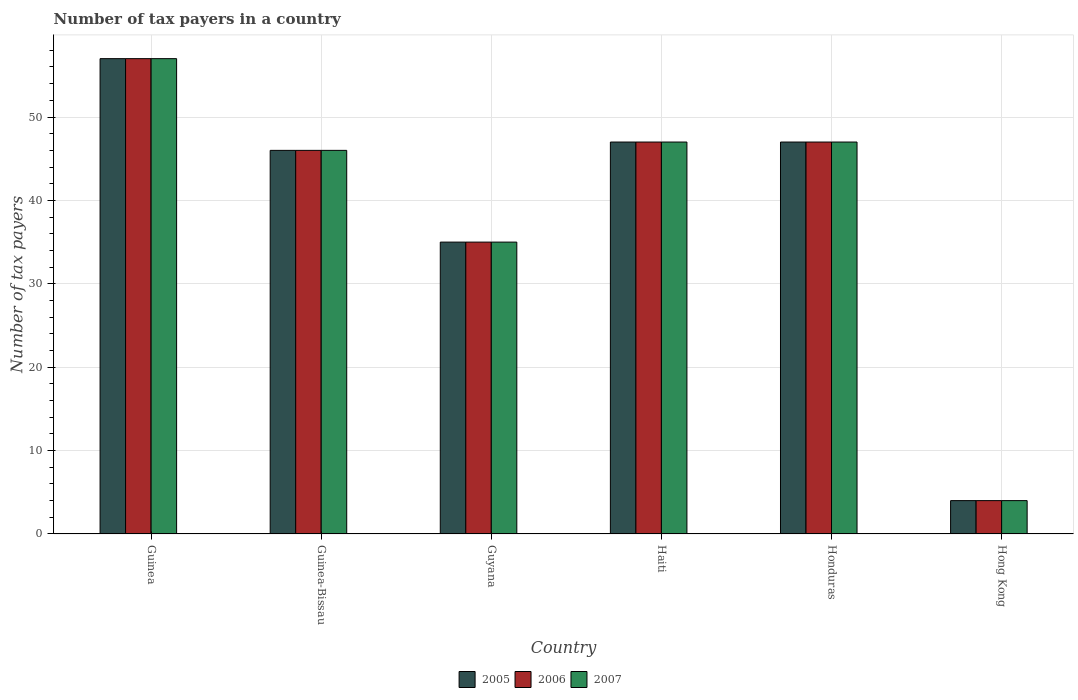How many different coloured bars are there?
Provide a short and direct response. 3. How many groups of bars are there?
Provide a succinct answer. 6. Are the number of bars per tick equal to the number of legend labels?
Make the answer very short. Yes. Are the number of bars on each tick of the X-axis equal?
Offer a very short reply. Yes. What is the label of the 6th group of bars from the left?
Offer a terse response. Hong Kong. In which country was the number of tax payers in in 2006 maximum?
Provide a succinct answer. Guinea. In which country was the number of tax payers in in 2006 minimum?
Your answer should be compact. Hong Kong. What is the total number of tax payers in in 2007 in the graph?
Your answer should be very brief. 236. What is the difference between the number of tax payers in in 2005 in Guinea and the number of tax payers in in 2007 in Honduras?
Make the answer very short. 10. What is the average number of tax payers in in 2005 per country?
Keep it short and to the point. 39.33. What is the ratio of the number of tax payers in in 2006 in Guyana to that in Haiti?
Your answer should be very brief. 0.74. Is the difference between the number of tax payers in in 2006 in Guyana and Haiti greater than the difference between the number of tax payers in in 2005 in Guyana and Haiti?
Provide a short and direct response. No. What is the difference between the highest and the second highest number of tax payers in in 2006?
Offer a terse response. 10. What is the difference between the highest and the lowest number of tax payers in in 2006?
Offer a terse response. 53. How many bars are there?
Make the answer very short. 18. How many countries are there in the graph?
Offer a terse response. 6. What is the difference between two consecutive major ticks on the Y-axis?
Your response must be concise. 10. Are the values on the major ticks of Y-axis written in scientific E-notation?
Ensure brevity in your answer.  No. Does the graph contain any zero values?
Make the answer very short. No. Where does the legend appear in the graph?
Make the answer very short. Bottom center. How many legend labels are there?
Your answer should be very brief. 3. How are the legend labels stacked?
Offer a very short reply. Horizontal. What is the title of the graph?
Ensure brevity in your answer.  Number of tax payers in a country. Does "2007" appear as one of the legend labels in the graph?
Your response must be concise. Yes. What is the label or title of the X-axis?
Offer a very short reply. Country. What is the label or title of the Y-axis?
Keep it short and to the point. Number of tax payers. What is the Number of tax payers of 2005 in Guinea?
Offer a terse response. 57. What is the Number of tax payers in 2005 in Guyana?
Provide a succinct answer. 35. What is the Number of tax payers in 2005 in Haiti?
Ensure brevity in your answer.  47. What is the Number of tax payers in 2006 in Haiti?
Offer a terse response. 47. What is the Number of tax payers of 2006 in Honduras?
Ensure brevity in your answer.  47. What is the Number of tax payers in 2005 in Hong Kong?
Ensure brevity in your answer.  4. Across all countries, what is the maximum Number of tax payers of 2005?
Give a very brief answer. 57. Across all countries, what is the minimum Number of tax payers of 2007?
Your response must be concise. 4. What is the total Number of tax payers in 2005 in the graph?
Offer a terse response. 236. What is the total Number of tax payers in 2006 in the graph?
Provide a short and direct response. 236. What is the total Number of tax payers of 2007 in the graph?
Your answer should be very brief. 236. What is the difference between the Number of tax payers in 2006 in Guinea and that in Guinea-Bissau?
Offer a terse response. 11. What is the difference between the Number of tax payers in 2007 in Guinea and that in Guinea-Bissau?
Keep it short and to the point. 11. What is the difference between the Number of tax payers in 2005 in Guinea and that in Guyana?
Provide a succinct answer. 22. What is the difference between the Number of tax payers in 2006 in Guinea and that in Haiti?
Your response must be concise. 10. What is the difference between the Number of tax payers in 2006 in Guinea and that in Honduras?
Offer a very short reply. 10. What is the difference between the Number of tax payers of 2007 in Guinea and that in Honduras?
Your response must be concise. 10. What is the difference between the Number of tax payers of 2006 in Guinea-Bissau and that in Guyana?
Provide a short and direct response. 11. What is the difference between the Number of tax payers of 2007 in Guinea-Bissau and that in Guyana?
Ensure brevity in your answer.  11. What is the difference between the Number of tax payers of 2006 in Guinea-Bissau and that in Haiti?
Your answer should be very brief. -1. What is the difference between the Number of tax payers of 2006 in Guinea-Bissau and that in Honduras?
Keep it short and to the point. -1. What is the difference between the Number of tax payers in 2006 in Guinea-Bissau and that in Hong Kong?
Provide a short and direct response. 42. What is the difference between the Number of tax payers of 2007 in Guyana and that in Haiti?
Ensure brevity in your answer.  -12. What is the difference between the Number of tax payers in 2006 in Guyana and that in Honduras?
Provide a short and direct response. -12. What is the difference between the Number of tax payers in 2005 in Guyana and that in Hong Kong?
Give a very brief answer. 31. What is the difference between the Number of tax payers of 2006 in Guyana and that in Hong Kong?
Provide a succinct answer. 31. What is the difference between the Number of tax payers in 2007 in Guyana and that in Hong Kong?
Provide a succinct answer. 31. What is the difference between the Number of tax payers in 2005 in Haiti and that in Honduras?
Ensure brevity in your answer.  0. What is the difference between the Number of tax payers in 2006 in Haiti and that in Honduras?
Your response must be concise. 0. What is the difference between the Number of tax payers of 2007 in Haiti and that in Hong Kong?
Offer a terse response. 43. What is the difference between the Number of tax payers of 2006 in Honduras and that in Hong Kong?
Your response must be concise. 43. What is the difference between the Number of tax payers in 2005 in Guinea and the Number of tax payers in 2006 in Guinea-Bissau?
Ensure brevity in your answer.  11. What is the difference between the Number of tax payers of 2005 in Guinea and the Number of tax payers of 2006 in Guyana?
Ensure brevity in your answer.  22. What is the difference between the Number of tax payers in 2005 in Guinea and the Number of tax payers in 2007 in Guyana?
Provide a succinct answer. 22. What is the difference between the Number of tax payers in 2006 in Guinea and the Number of tax payers in 2007 in Guyana?
Make the answer very short. 22. What is the difference between the Number of tax payers in 2006 in Guinea and the Number of tax payers in 2007 in Haiti?
Give a very brief answer. 10. What is the difference between the Number of tax payers of 2005 in Guinea and the Number of tax payers of 2006 in Honduras?
Your response must be concise. 10. What is the difference between the Number of tax payers of 2005 in Guinea and the Number of tax payers of 2007 in Honduras?
Offer a very short reply. 10. What is the difference between the Number of tax payers in 2005 in Guinea and the Number of tax payers in 2007 in Hong Kong?
Make the answer very short. 53. What is the difference between the Number of tax payers of 2006 in Guinea and the Number of tax payers of 2007 in Hong Kong?
Ensure brevity in your answer.  53. What is the difference between the Number of tax payers of 2005 in Guinea-Bissau and the Number of tax payers of 2006 in Guyana?
Give a very brief answer. 11. What is the difference between the Number of tax payers of 2006 in Guinea-Bissau and the Number of tax payers of 2007 in Guyana?
Ensure brevity in your answer.  11. What is the difference between the Number of tax payers of 2006 in Guinea-Bissau and the Number of tax payers of 2007 in Haiti?
Give a very brief answer. -1. What is the difference between the Number of tax payers of 2005 in Guinea-Bissau and the Number of tax payers of 2006 in Hong Kong?
Provide a succinct answer. 42. What is the difference between the Number of tax payers in 2006 in Guinea-Bissau and the Number of tax payers in 2007 in Hong Kong?
Provide a succinct answer. 42. What is the difference between the Number of tax payers in 2005 in Guyana and the Number of tax payers in 2006 in Haiti?
Give a very brief answer. -12. What is the difference between the Number of tax payers of 2006 in Guyana and the Number of tax payers of 2007 in Haiti?
Offer a terse response. -12. What is the difference between the Number of tax payers in 2005 in Guyana and the Number of tax payers in 2006 in Honduras?
Provide a short and direct response. -12. What is the difference between the Number of tax payers of 2005 in Guyana and the Number of tax payers of 2007 in Honduras?
Provide a short and direct response. -12. What is the difference between the Number of tax payers of 2005 in Guyana and the Number of tax payers of 2006 in Hong Kong?
Your response must be concise. 31. What is the difference between the Number of tax payers in 2006 in Guyana and the Number of tax payers in 2007 in Hong Kong?
Your response must be concise. 31. What is the difference between the Number of tax payers of 2006 in Haiti and the Number of tax payers of 2007 in Honduras?
Keep it short and to the point. 0. What is the difference between the Number of tax payers of 2005 in Haiti and the Number of tax payers of 2007 in Hong Kong?
Give a very brief answer. 43. What is the difference between the Number of tax payers in 2006 in Haiti and the Number of tax payers in 2007 in Hong Kong?
Keep it short and to the point. 43. What is the difference between the Number of tax payers of 2005 in Honduras and the Number of tax payers of 2007 in Hong Kong?
Offer a terse response. 43. What is the difference between the Number of tax payers of 2006 in Honduras and the Number of tax payers of 2007 in Hong Kong?
Make the answer very short. 43. What is the average Number of tax payers in 2005 per country?
Make the answer very short. 39.33. What is the average Number of tax payers in 2006 per country?
Keep it short and to the point. 39.33. What is the average Number of tax payers in 2007 per country?
Your answer should be compact. 39.33. What is the difference between the Number of tax payers of 2005 and Number of tax payers of 2007 in Guinea?
Your response must be concise. 0. What is the difference between the Number of tax payers in 2005 and Number of tax payers in 2007 in Guinea-Bissau?
Give a very brief answer. 0. What is the difference between the Number of tax payers of 2006 and Number of tax payers of 2007 in Guyana?
Give a very brief answer. 0. What is the difference between the Number of tax payers in 2005 and Number of tax payers in 2006 in Honduras?
Offer a very short reply. 0. What is the difference between the Number of tax payers of 2005 and Number of tax payers of 2006 in Hong Kong?
Ensure brevity in your answer.  0. What is the difference between the Number of tax payers in 2006 and Number of tax payers in 2007 in Hong Kong?
Your answer should be very brief. 0. What is the ratio of the Number of tax payers of 2005 in Guinea to that in Guinea-Bissau?
Ensure brevity in your answer.  1.24. What is the ratio of the Number of tax payers in 2006 in Guinea to that in Guinea-Bissau?
Ensure brevity in your answer.  1.24. What is the ratio of the Number of tax payers of 2007 in Guinea to that in Guinea-Bissau?
Your answer should be compact. 1.24. What is the ratio of the Number of tax payers of 2005 in Guinea to that in Guyana?
Your answer should be compact. 1.63. What is the ratio of the Number of tax payers in 2006 in Guinea to that in Guyana?
Give a very brief answer. 1.63. What is the ratio of the Number of tax payers of 2007 in Guinea to that in Guyana?
Your answer should be very brief. 1.63. What is the ratio of the Number of tax payers of 2005 in Guinea to that in Haiti?
Keep it short and to the point. 1.21. What is the ratio of the Number of tax payers of 2006 in Guinea to that in Haiti?
Your response must be concise. 1.21. What is the ratio of the Number of tax payers of 2007 in Guinea to that in Haiti?
Give a very brief answer. 1.21. What is the ratio of the Number of tax payers in 2005 in Guinea to that in Honduras?
Your answer should be very brief. 1.21. What is the ratio of the Number of tax payers of 2006 in Guinea to that in Honduras?
Offer a very short reply. 1.21. What is the ratio of the Number of tax payers in 2007 in Guinea to that in Honduras?
Provide a short and direct response. 1.21. What is the ratio of the Number of tax payers of 2005 in Guinea to that in Hong Kong?
Offer a terse response. 14.25. What is the ratio of the Number of tax payers of 2006 in Guinea to that in Hong Kong?
Provide a short and direct response. 14.25. What is the ratio of the Number of tax payers of 2007 in Guinea to that in Hong Kong?
Your answer should be compact. 14.25. What is the ratio of the Number of tax payers in 2005 in Guinea-Bissau to that in Guyana?
Ensure brevity in your answer.  1.31. What is the ratio of the Number of tax payers in 2006 in Guinea-Bissau to that in Guyana?
Make the answer very short. 1.31. What is the ratio of the Number of tax payers of 2007 in Guinea-Bissau to that in Guyana?
Provide a short and direct response. 1.31. What is the ratio of the Number of tax payers of 2005 in Guinea-Bissau to that in Haiti?
Provide a succinct answer. 0.98. What is the ratio of the Number of tax payers in 2006 in Guinea-Bissau to that in Haiti?
Make the answer very short. 0.98. What is the ratio of the Number of tax payers in 2007 in Guinea-Bissau to that in Haiti?
Your answer should be very brief. 0.98. What is the ratio of the Number of tax payers in 2005 in Guinea-Bissau to that in Honduras?
Provide a short and direct response. 0.98. What is the ratio of the Number of tax payers of 2006 in Guinea-Bissau to that in Honduras?
Your answer should be compact. 0.98. What is the ratio of the Number of tax payers of 2007 in Guinea-Bissau to that in Honduras?
Make the answer very short. 0.98. What is the ratio of the Number of tax payers in 2005 in Guinea-Bissau to that in Hong Kong?
Ensure brevity in your answer.  11.5. What is the ratio of the Number of tax payers of 2005 in Guyana to that in Haiti?
Your answer should be very brief. 0.74. What is the ratio of the Number of tax payers in 2006 in Guyana to that in Haiti?
Ensure brevity in your answer.  0.74. What is the ratio of the Number of tax payers of 2007 in Guyana to that in Haiti?
Provide a succinct answer. 0.74. What is the ratio of the Number of tax payers in 2005 in Guyana to that in Honduras?
Offer a very short reply. 0.74. What is the ratio of the Number of tax payers of 2006 in Guyana to that in Honduras?
Provide a succinct answer. 0.74. What is the ratio of the Number of tax payers in 2007 in Guyana to that in Honduras?
Offer a terse response. 0.74. What is the ratio of the Number of tax payers of 2005 in Guyana to that in Hong Kong?
Provide a succinct answer. 8.75. What is the ratio of the Number of tax payers of 2006 in Guyana to that in Hong Kong?
Ensure brevity in your answer.  8.75. What is the ratio of the Number of tax payers in 2007 in Guyana to that in Hong Kong?
Ensure brevity in your answer.  8.75. What is the ratio of the Number of tax payers in 2005 in Haiti to that in Honduras?
Make the answer very short. 1. What is the ratio of the Number of tax payers of 2006 in Haiti to that in Honduras?
Ensure brevity in your answer.  1. What is the ratio of the Number of tax payers in 2005 in Haiti to that in Hong Kong?
Give a very brief answer. 11.75. What is the ratio of the Number of tax payers of 2006 in Haiti to that in Hong Kong?
Give a very brief answer. 11.75. What is the ratio of the Number of tax payers of 2007 in Haiti to that in Hong Kong?
Keep it short and to the point. 11.75. What is the ratio of the Number of tax payers of 2005 in Honduras to that in Hong Kong?
Provide a succinct answer. 11.75. What is the ratio of the Number of tax payers of 2006 in Honduras to that in Hong Kong?
Make the answer very short. 11.75. What is the ratio of the Number of tax payers of 2007 in Honduras to that in Hong Kong?
Offer a very short reply. 11.75. What is the difference between the highest and the second highest Number of tax payers of 2005?
Offer a terse response. 10. What is the difference between the highest and the second highest Number of tax payers in 2006?
Offer a very short reply. 10. What is the difference between the highest and the lowest Number of tax payers of 2005?
Provide a succinct answer. 53. 